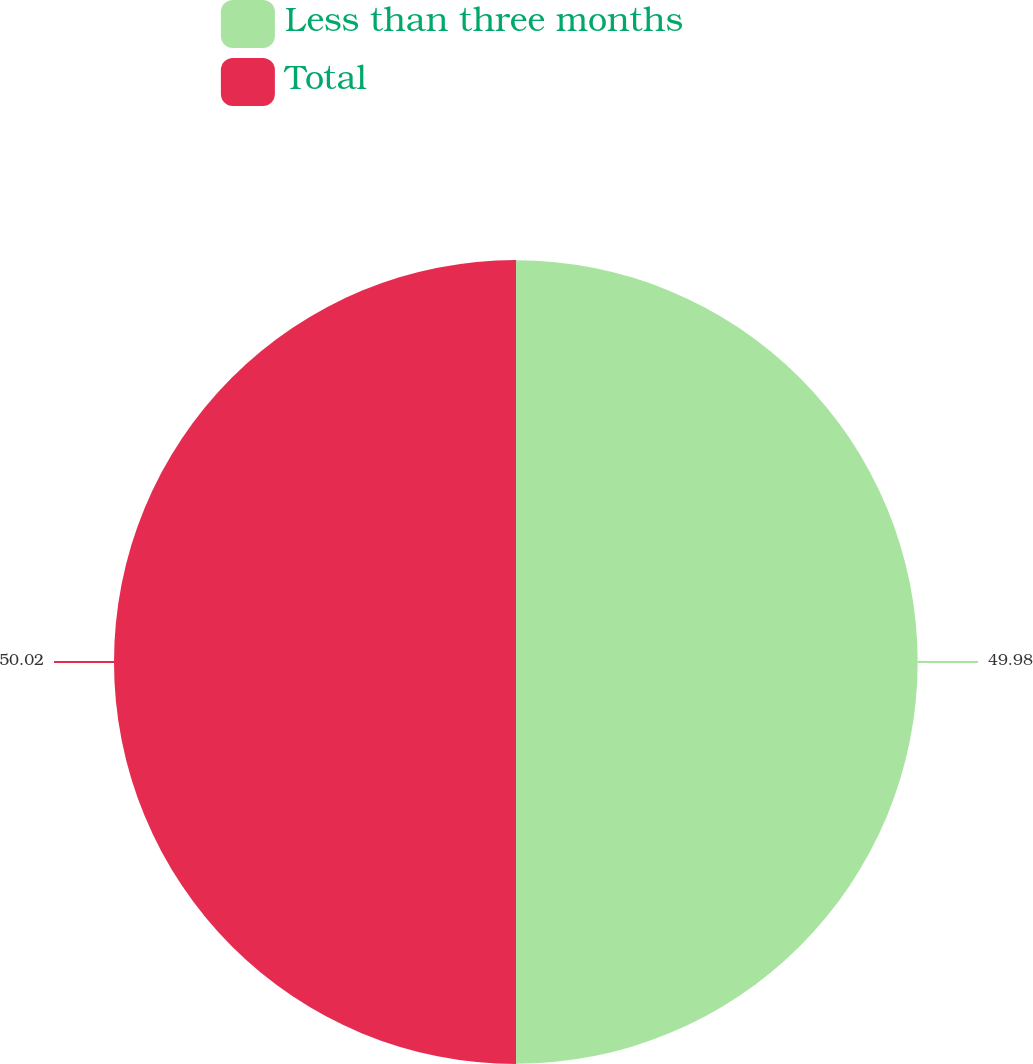Convert chart to OTSL. <chart><loc_0><loc_0><loc_500><loc_500><pie_chart><fcel>Less than three months<fcel>Total<nl><fcel>49.98%<fcel>50.02%<nl></chart> 